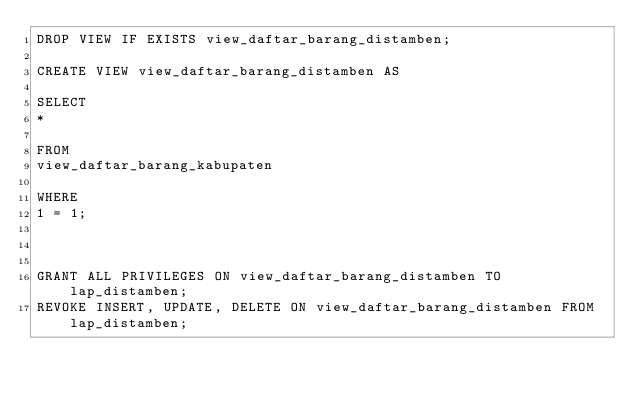Convert code to text. <code><loc_0><loc_0><loc_500><loc_500><_SQL_>DROP VIEW IF EXISTS view_daftar_barang_distamben;

CREATE VIEW view_daftar_barang_distamben AS

SELECT
*

FROM
view_daftar_barang_kabupaten

WHERE
1 = 1;



GRANT ALL PRIVILEGES ON view_daftar_barang_distamben TO lap_distamben;
REVOKE INSERT, UPDATE, DELETE ON view_daftar_barang_distamben FROM lap_distamben;
</code> 